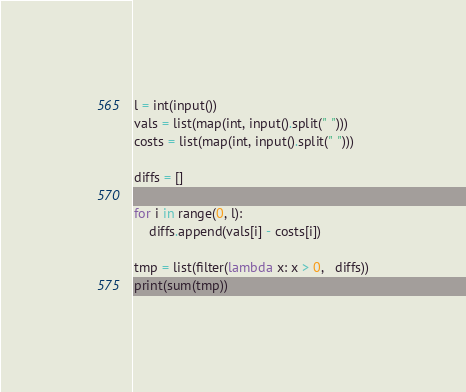Convert code to text. <code><loc_0><loc_0><loc_500><loc_500><_Python_>l = int(input())
vals = list(map(int, input().split(" ")))
costs = list(map(int, input().split(" ")))

diffs = []

for i in range(0, l):
    diffs.append(vals[i] - costs[i])

tmp = list(filter(lambda x: x > 0,   diffs))
print(sum(tmp))</code> 